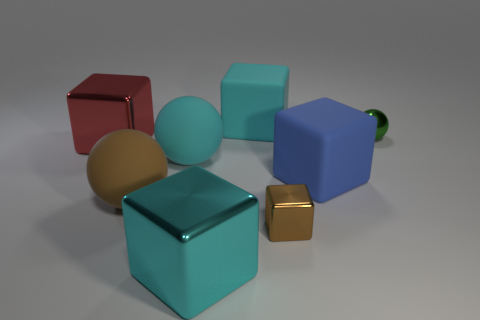Can you tell me what shapes are present in the image and their colors? Certainly! The image features a variety of geometric shapes. There is a red cube, a large cyan cube, a small shiny gold cube, a beige sphere, a medium-sized cyan sphere, and a blue cube with a green cylindrical object attached to it. 